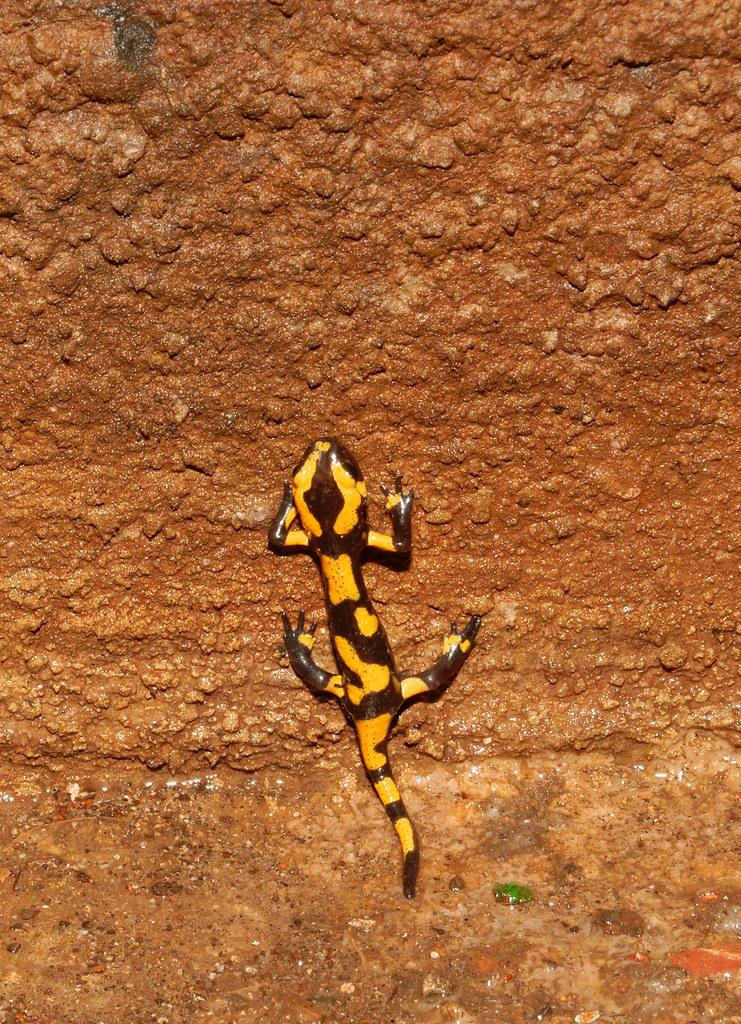What type of animal is present in the image? There is a lizard in the image. Can you describe the location of the lizard in the image? The lizard is on the surface in the image. What type of payment method is accepted by the lizard in the image? There is no indication in the image that the lizard is involved in any payment transactions. 